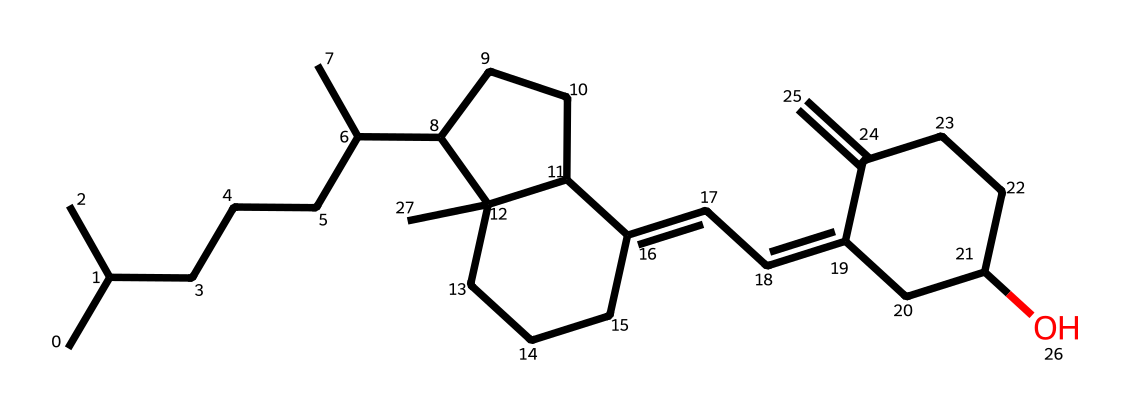What is the molecular formula of vitamin D represented by this SMILES? To derive the molecular formula from the SMILES, we count the carbon (C), hydrogen (H), and oxygen (O) atoms present in the structure. The parsed structure contains 27 carbon atoms, 46 hydrogen atoms, and 1 oxygen atom, which gives us the formula C27H46O.
Answer: C27H46O How many rings are present in the structure of vitamin D? By examining the SMILES structure, we identify the cyclic sections between the numbers 1 and 2, which indicate two rings in total. Thus, the answer is derived by counting those distinct ring indicators.
Answer: 2 What functional group is present in vitamin D? The presence of the hydroxyl (–OH) group can be detected in the structure, represented by the "O" at the end connected to a carbon. This functional group classifies vitamin D as an alcohol.
Answer: hydroxyl What is the role of vitamin D in bone health? Vitamin D facilitates the absorption of calcium and phosphate, critical for maintaining bone density and strength. By enhancing mineral absorption, it plays a pivotal role in bone remodeling and overall skeletal health.
Answer: calcium absorption Which base molecule structure does vitamin D derive from? The structure of vitamin D is based on cholesterol, a type of sterol. The arrangement of the rings and alkyl chains in the chemical structure can be directly correlated to that of cholesterol, with specific modifications for its active form as a vitamin.
Answer: cholesterol How many double bonds are found in the structure of vitamin D? In the given SMILES structure, we can identify double bonds by locating the "=" symbols. Upon examining the structure, we find three double bonds present in vitamin D's molecular composition.
Answer: 3 